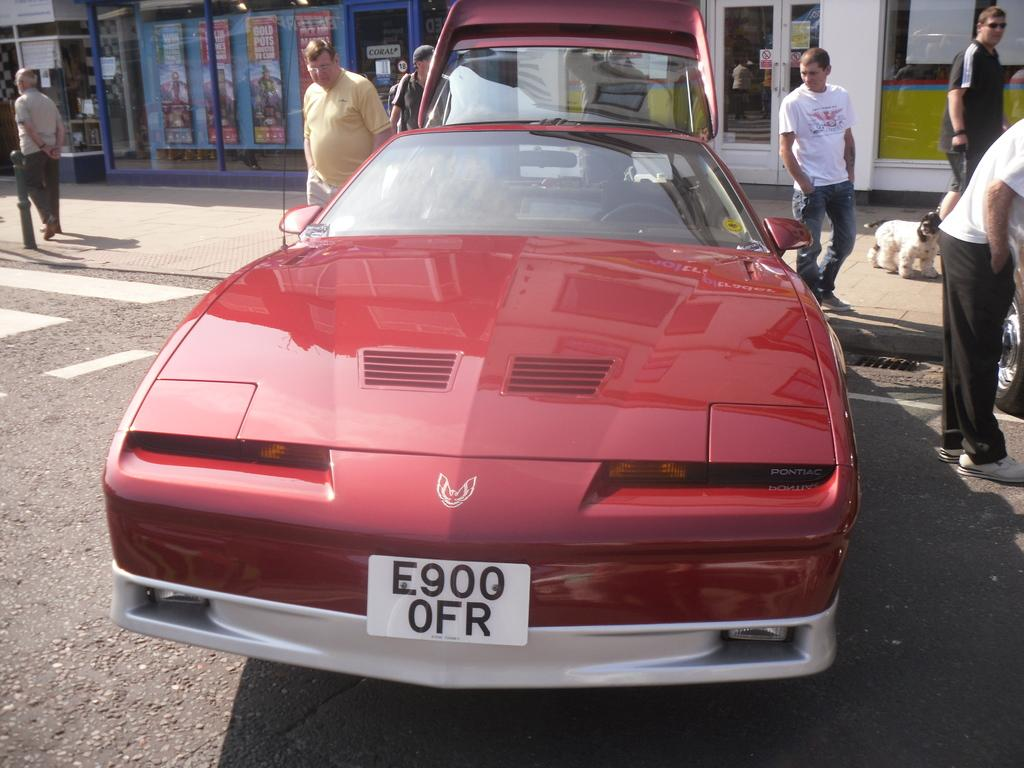What is the main subject of the image? There is a car on the road in the image. Can you describe any other elements in the image? Yes, there are people visible in the image. What is located in the background of the image? There is a door in the background of the image. What type of humor can be seen in the image? There is no humor present in the image; it features a car on the road, people, and a door in the background. What role does the cabbage play in the image? There is no cabbage present in the image. 